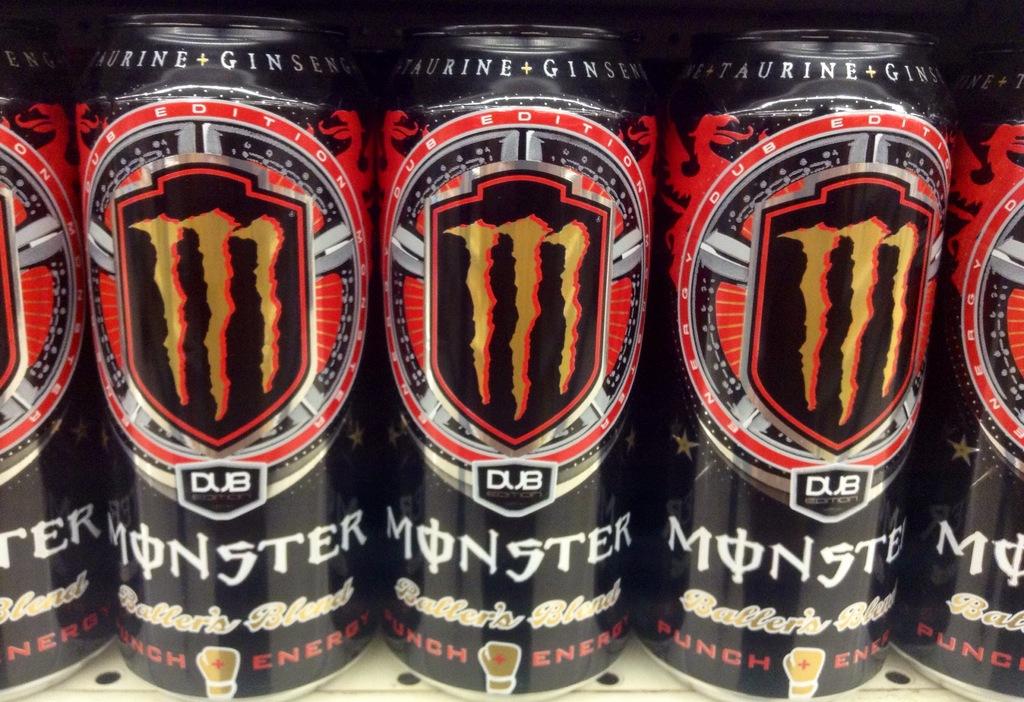What flavor is the energy drink?
Your response must be concise. Baller's blend. What is the brand of this drink?
Keep it short and to the point. Monster. 